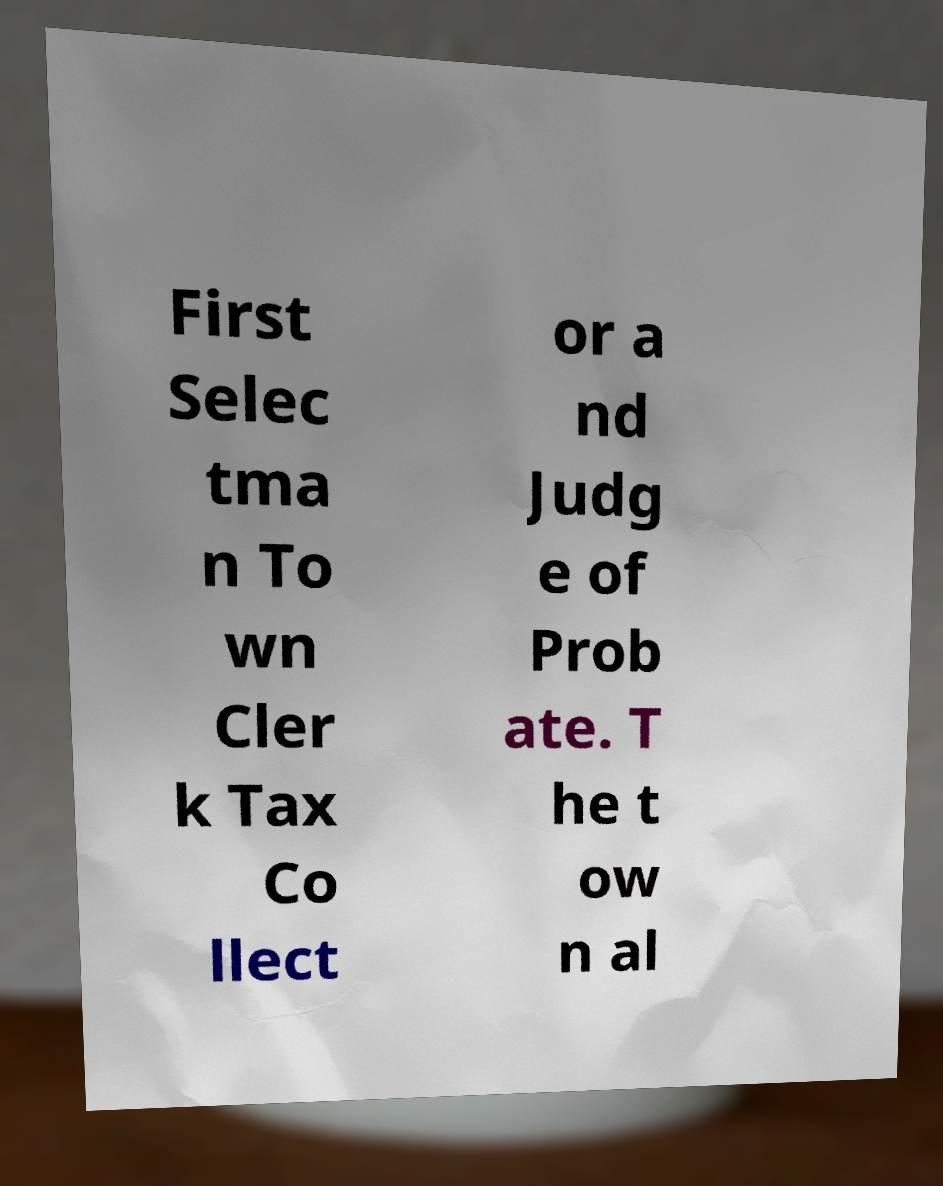What messages or text are displayed in this image? I need them in a readable, typed format. First Selec tma n To wn Cler k Tax Co llect or a nd Judg e of Prob ate. T he t ow n al 